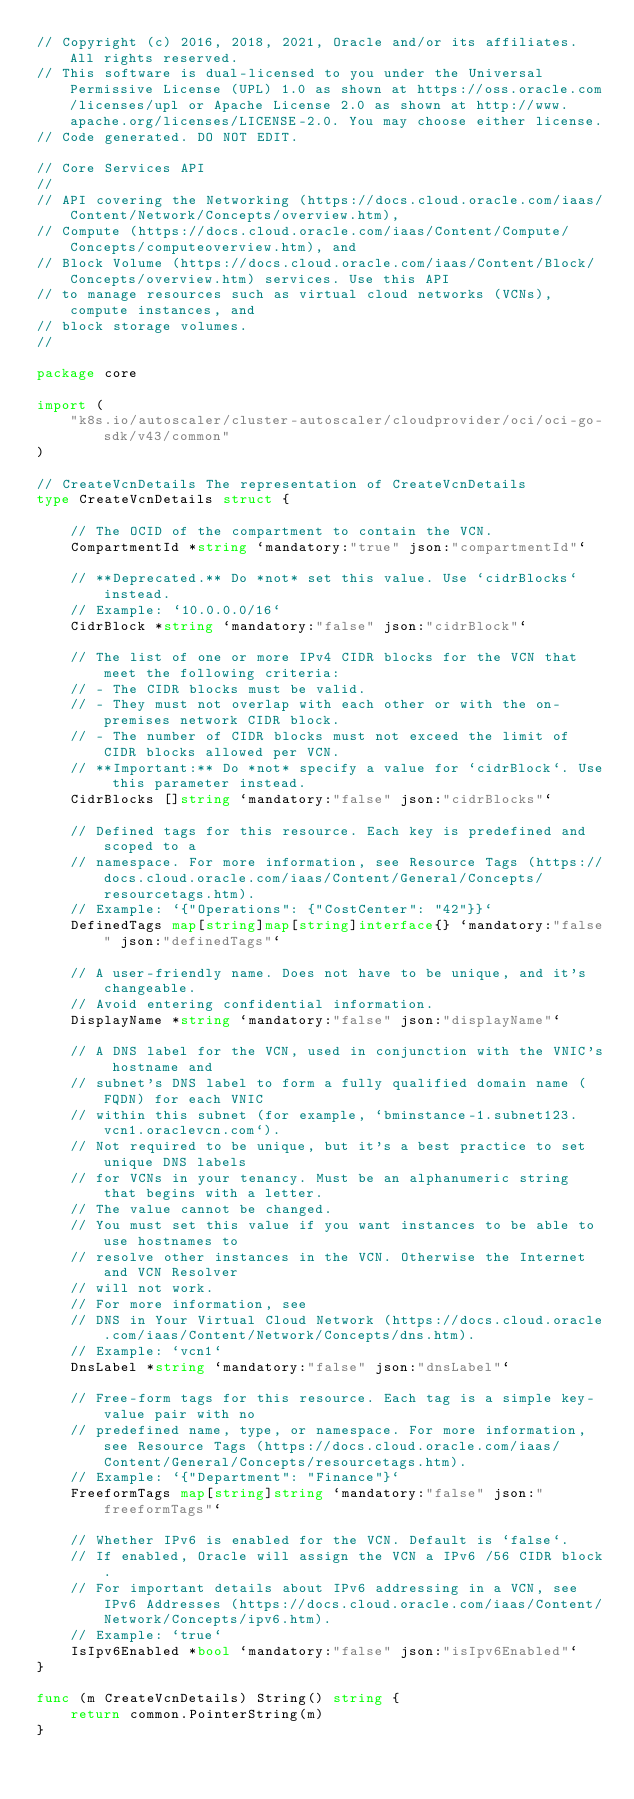Convert code to text. <code><loc_0><loc_0><loc_500><loc_500><_Go_>// Copyright (c) 2016, 2018, 2021, Oracle and/or its affiliates.  All rights reserved.
// This software is dual-licensed to you under the Universal Permissive License (UPL) 1.0 as shown at https://oss.oracle.com/licenses/upl or Apache License 2.0 as shown at http://www.apache.org/licenses/LICENSE-2.0. You may choose either license.
// Code generated. DO NOT EDIT.

// Core Services API
//
// API covering the Networking (https://docs.cloud.oracle.com/iaas/Content/Network/Concepts/overview.htm),
// Compute (https://docs.cloud.oracle.com/iaas/Content/Compute/Concepts/computeoverview.htm), and
// Block Volume (https://docs.cloud.oracle.com/iaas/Content/Block/Concepts/overview.htm) services. Use this API
// to manage resources such as virtual cloud networks (VCNs), compute instances, and
// block storage volumes.
//

package core

import (
	"k8s.io/autoscaler/cluster-autoscaler/cloudprovider/oci/oci-go-sdk/v43/common"
)

// CreateVcnDetails The representation of CreateVcnDetails
type CreateVcnDetails struct {

	// The OCID of the compartment to contain the VCN.
	CompartmentId *string `mandatory:"true" json:"compartmentId"`

	// **Deprecated.** Do *not* set this value. Use `cidrBlocks` instead.
	// Example: `10.0.0.0/16`
	CidrBlock *string `mandatory:"false" json:"cidrBlock"`

	// The list of one or more IPv4 CIDR blocks for the VCN that meet the following criteria:
	// - The CIDR blocks must be valid.
	// - They must not overlap with each other or with the on-premises network CIDR block.
	// - The number of CIDR blocks must not exceed the limit of CIDR blocks allowed per VCN.
	// **Important:** Do *not* specify a value for `cidrBlock`. Use this parameter instead.
	CidrBlocks []string `mandatory:"false" json:"cidrBlocks"`

	// Defined tags for this resource. Each key is predefined and scoped to a
	// namespace. For more information, see Resource Tags (https://docs.cloud.oracle.com/iaas/Content/General/Concepts/resourcetags.htm).
	// Example: `{"Operations": {"CostCenter": "42"}}`
	DefinedTags map[string]map[string]interface{} `mandatory:"false" json:"definedTags"`

	// A user-friendly name. Does not have to be unique, and it's changeable.
	// Avoid entering confidential information.
	DisplayName *string `mandatory:"false" json:"displayName"`

	// A DNS label for the VCN, used in conjunction with the VNIC's hostname and
	// subnet's DNS label to form a fully qualified domain name (FQDN) for each VNIC
	// within this subnet (for example, `bminstance-1.subnet123.vcn1.oraclevcn.com`).
	// Not required to be unique, but it's a best practice to set unique DNS labels
	// for VCNs in your tenancy. Must be an alphanumeric string that begins with a letter.
	// The value cannot be changed.
	// You must set this value if you want instances to be able to use hostnames to
	// resolve other instances in the VCN. Otherwise the Internet and VCN Resolver
	// will not work.
	// For more information, see
	// DNS in Your Virtual Cloud Network (https://docs.cloud.oracle.com/iaas/Content/Network/Concepts/dns.htm).
	// Example: `vcn1`
	DnsLabel *string `mandatory:"false" json:"dnsLabel"`

	// Free-form tags for this resource. Each tag is a simple key-value pair with no
	// predefined name, type, or namespace. For more information, see Resource Tags (https://docs.cloud.oracle.com/iaas/Content/General/Concepts/resourcetags.htm).
	// Example: `{"Department": "Finance"}`
	FreeformTags map[string]string `mandatory:"false" json:"freeformTags"`

	// Whether IPv6 is enabled for the VCN. Default is `false`.
	// If enabled, Oracle will assign the VCN a IPv6 /56 CIDR block.
	// For important details about IPv6 addressing in a VCN, see IPv6 Addresses (https://docs.cloud.oracle.com/iaas/Content/Network/Concepts/ipv6.htm).
	// Example: `true`
	IsIpv6Enabled *bool `mandatory:"false" json:"isIpv6Enabled"`
}

func (m CreateVcnDetails) String() string {
	return common.PointerString(m)
}
</code> 